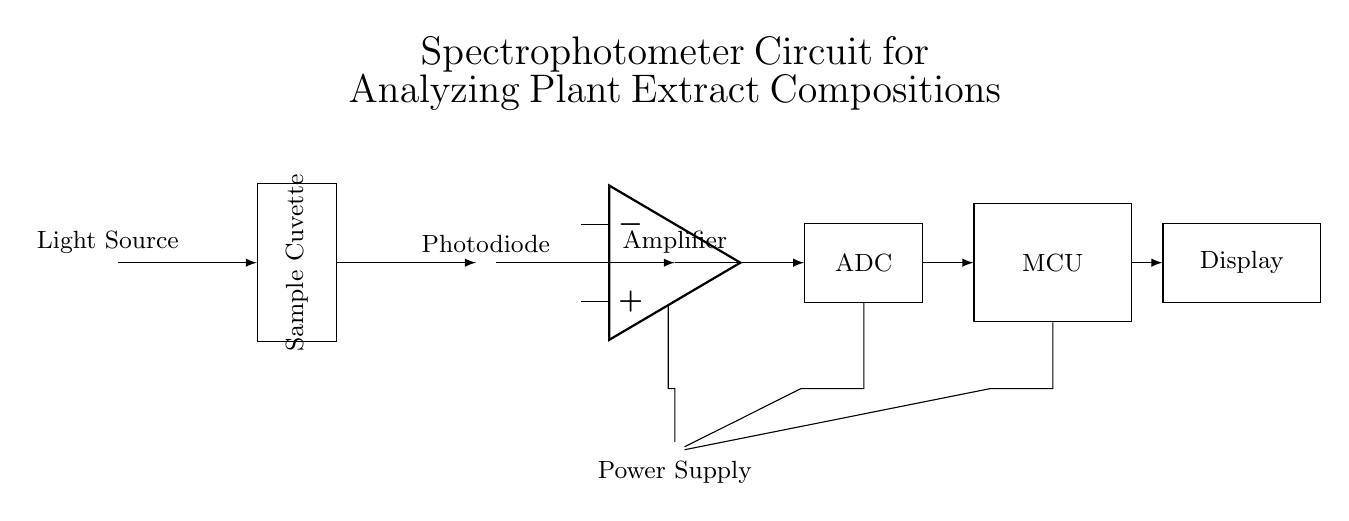What is the purpose of the photodiode in this circuit? The photodiode detects the intensity of light that has passed through the sample cuvette. It converts light into an electrical current that is proportional to the light intensity.
Answer: Detect light intensity What type of amplifier is used in the circuit? The circuit uses an operational amplifier (op amp). This type of amplifier is commonly used for processing analog signals, providing signal conditioning for the photodiode output.
Answer: Operational amplifier Which component displays the results of the analysis? The display component shows the results of the analysis conducted by the microcontroller. It interfaces with the microcontroller to present data visually to the user.
Answer: Display What is the order of signal processing in this spectrophotometer circuit? The light from the source passes through the sample, detected by the photodiode, amplified, converted by the ADC, processed by the microcontroller, and finally displayed.
Answer: Light source, sample, photodiode, amplifier, ADC, MCU, display How is power supplied to the amplifier and other components? The power supply distributes voltage to the amplifier, ADC, and microcontroller, ensuring they have the operating voltage necessary for their functions. Each component receives power through direct connections from the main power source.
Answer: Power supply What role does the microcontroller play in the spectrophotometer circuit? The microcontroller processes the data received from the ADC, controls the operation of the circuit, and sends the processed results to the display for output.
Answer: Data processing What type of input does the ADC in this circuit receive? The ADC receives an analog voltage signal from the operational amplifier, which corresponds to the optical density of the sample. This signal is then converted to a digital format for processing by the microcontroller.
Answer: Analog voltage signal 